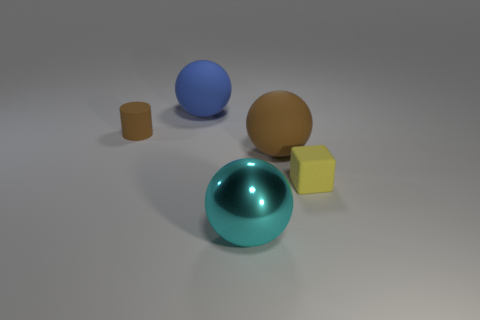Subtract all red spheres. Subtract all green blocks. How many spheres are left? 3 Add 5 blue rubber spheres. How many objects exist? 10 Subtract all blocks. How many objects are left? 4 Add 2 big brown things. How many big brown things are left? 3 Add 4 large cyan matte blocks. How many large cyan matte blocks exist? 4 Subtract 0 purple spheres. How many objects are left? 5 Subtract all tiny yellow objects. Subtract all blocks. How many objects are left? 3 